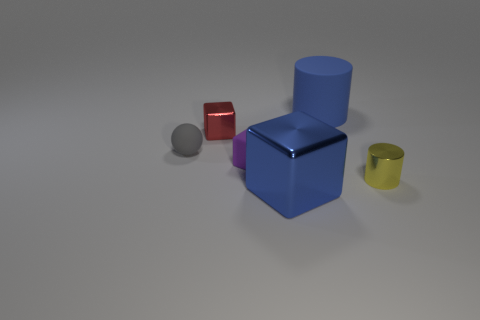Add 2 big blue rubber blocks. How many objects exist? 8 Subtract all cylinders. How many objects are left? 4 Add 3 purple matte cubes. How many purple matte cubes exist? 4 Subtract 0 brown balls. How many objects are left? 6 Subtract all yellow matte blocks. Subtract all tiny red metal blocks. How many objects are left? 5 Add 6 matte things. How many matte things are left? 9 